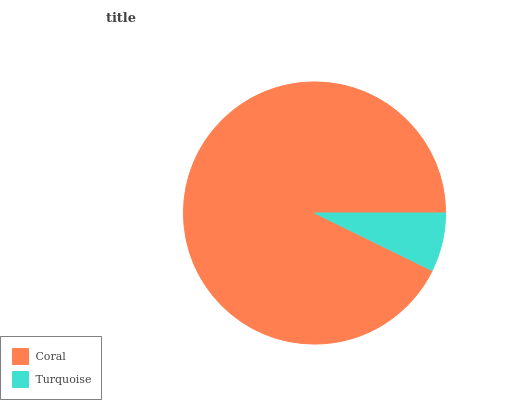Is Turquoise the minimum?
Answer yes or no. Yes. Is Coral the maximum?
Answer yes or no. Yes. Is Turquoise the maximum?
Answer yes or no. No. Is Coral greater than Turquoise?
Answer yes or no. Yes. Is Turquoise less than Coral?
Answer yes or no. Yes. Is Turquoise greater than Coral?
Answer yes or no. No. Is Coral less than Turquoise?
Answer yes or no. No. Is Coral the high median?
Answer yes or no. Yes. Is Turquoise the low median?
Answer yes or no. Yes. Is Turquoise the high median?
Answer yes or no. No. Is Coral the low median?
Answer yes or no. No. 